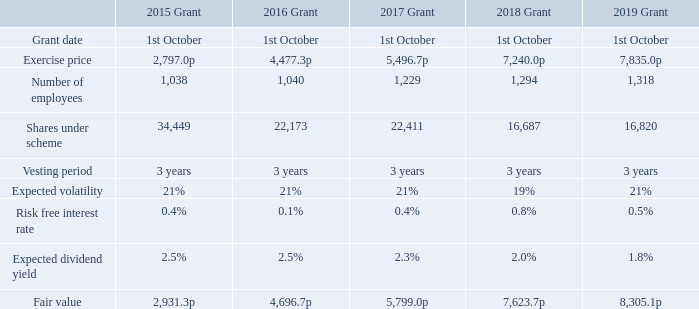Employee Share Ownership Plan
UK employees are eligible to participate in the Employee Share Ownership Plan (ESOP). The aim of the ESOP is to encourage increased shareholding in the Company by all UK employees and so there are no performance conditions. Employees are invited to join the ESOP when an offer is made each year. Individuals save for 12 months during the accumulation period and subscribe for shares at the lower of the price at the beginning and the end of the accumulation period under HMRC rules. The Company provides a matching share for each share purchased by the individual.
Shares issued under the ESOP have been measured using the Present Economic Value (PEV) valuation methodology. The relevant disclosures in respect of the Employee Share Ownership Plans are set out below.
The accumulation period for the 2019 ESOP ends in September 2020, therefore some figures are projections.
What is the aim of the ESOP? To encourage increased shareholding in the company by all uk employees and so there are no performance conditions. When does the accumulation period for the 2019 ESOP end? September 2020. For which years of share issuance are the relevant disclosures in respect of the Employee Share Ownership Plans analysed? 2015, 2016, 2017, 2018, 2019. In which grant year was the risk free interest rate the highest? 0.8%>0.5%>0.4%>0.1%
Answer: 2018. What was the change in the number of employees in 2019 from 2018? 1,318-1,294
Answer: 24. What was the percentage change in the number of employees in 2019 from 2018?
Answer scale should be: percent. (1,318-1,294)/1,294
Answer: 1.85. 